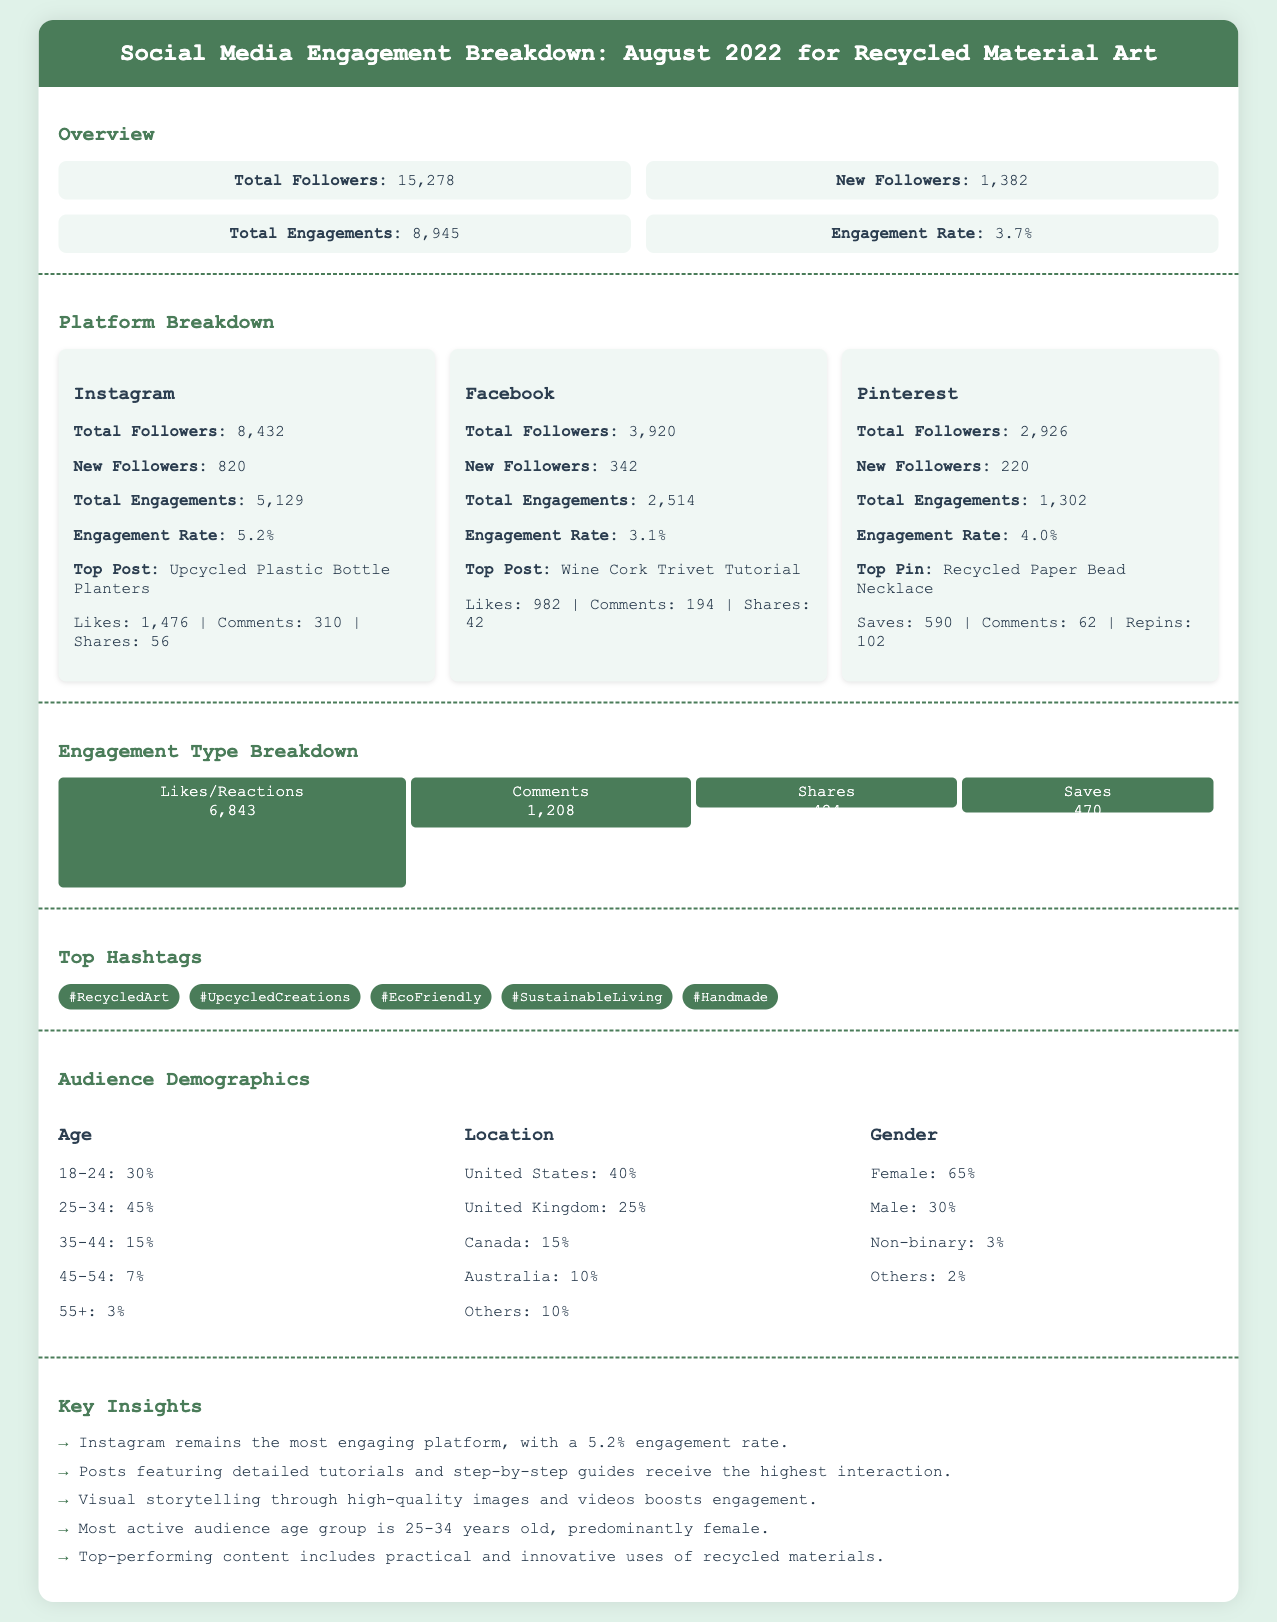what is the total number of followers? The total number of followers is stated in the overview section, which summarizes the counts across platforms.
Answer: 15,278 what was the new follower count on Facebook? The new follower count on Facebook is found in the platform breakdown section specifically under Facebook.
Answer: 342 which platform had the highest engagement rate? The engagement rate for each platform is provided in the platform breakdown, and the highest value indicates the most engaging platform.
Answer: Instagram what percentage of the audience is aged 25-34? The percentage for each age demographic is listed under audience demographics, with a specific percentage noted for the 25-34 age group.
Answer: 45% which post received the most likes on Instagram? The top post is highlighted in the platform breakdown under Instagram, detailing various metrics including likes.
Answer: Upcycled Plastic Bottle Planters what type of content received the highest interaction? The insights section summarizes observations on content types, indicating which kinds perform better based on engagement metrics.
Answer: Detailed tutorials how many total engagements were recorded across all platforms? The total engagements are summarized in the overview section, representing the sum of engagements from all platforms.
Answer: 8,945 what is the engagement rate for Pinterest? The engagement rate specific to Pinterest is mentioned in the platform breakdown section under Pinterest metrics.
Answer: 4.0% what is the most active audience age group? The audience demographics section notes which age group is most active, based on the percentage distribution noted there.
Answer: 25-34 